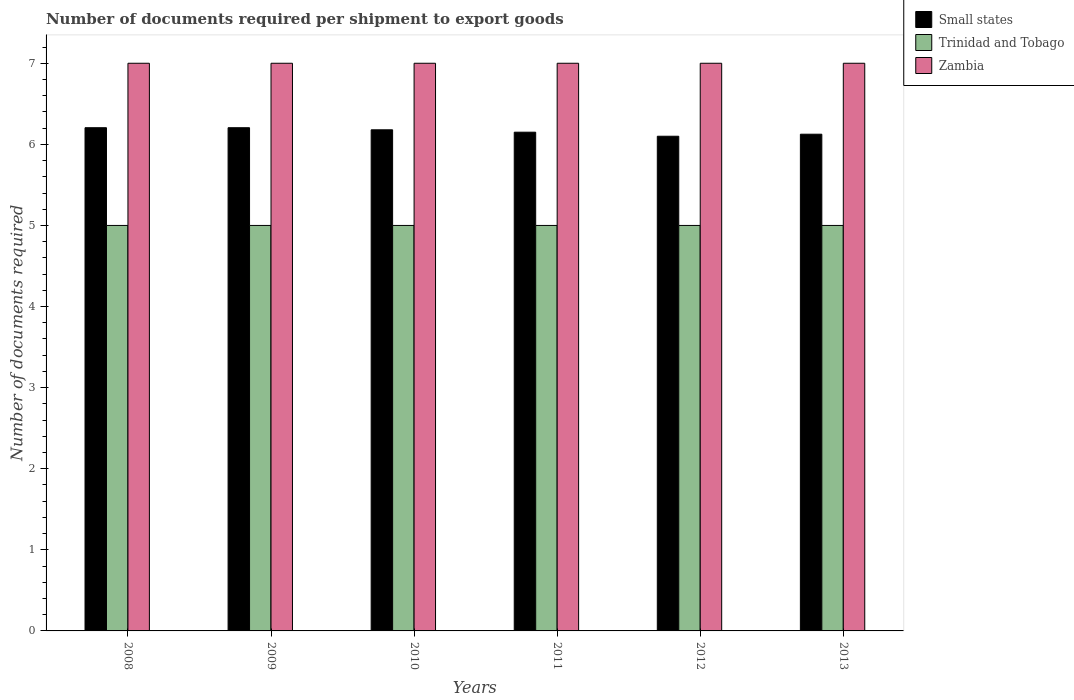Are the number of bars on each tick of the X-axis equal?
Keep it short and to the point. Yes. How many bars are there on the 1st tick from the left?
Offer a very short reply. 3. How many bars are there on the 2nd tick from the right?
Give a very brief answer. 3. What is the label of the 5th group of bars from the left?
Provide a succinct answer. 2012. What is the number of documents required per shipment to export goods in Small states in 2011?
Your response must be concise. 6.15. Across all years, what is the maximum number of documents required per shipment to export goods in Small states?
Your answer should be compact. 6.21. In which year was the number of documents required per shipment to export goods in Trinidad and Tobago maximum?
Offer a terse response. 2008. In which year was the number of documents required per shipment to export goods in Small states minimum?
Offer a very short reply. 2012. What is the total number of documents required per shipment to export goods in Small states in the graph?
Your answer should be compact. 36.96. What is the difference between the number of documents required per shipment to export goods in Trinidad and Tobago in 2011 and the number of documents required per shipment to export goods in Zambia in 2009?
Your answer should be very brief. -2. In the year 2010, what is the difference between the number of documents required per shipment to export goods in Zambia and number of documents required per shipment to export goods in Trinidad and Tobago?
Keep it short and to the point. 2. What is the ratio of the number of documents required per shipment to export goods in Trinidad and Tobago in 2012 to that in 2013?
Give a very brief answer. 1. Is the number of documents required per shipment to export goods in Small states in 2008 less than that in 2009?
Make the answer very short. No. Is the difference between the number of documents required per shipment to export goods in Zambia in 2008 and 2012 greater than the difference between the number of documents required per shipment to export goods in Trinidad and Tobago in 2008 and 2012?
Your answer should be compact. No. Is the sum of the number of documents required per shipment to export goods in Trinidad and Tobago in 2009 and 2011 greater than the maximum number of documents required per shipment to export goods in Zambia across all years?
Offer a very short reply. Yes. What does the 2nd bar from the left in 2012 represents?
Provide a succinct answer. Trinidad and Tobago. What does the 3rd bar from the right in 2009 represents?
Give a very brief answer. Small states. How many bars are there?
Provide a short and direct response. 18. Are all the bars in the graph horizontal?
Your response must be concise. No. Does the graph contain any zero values?
Provide a short and direct response. No. Where does the legend appear in the graph?
Ensure brevity in your answer.  Top right. How many legend labels are there?
Give a very brief answer. 3. What is the title of the graph?
Provide a short and direct response. Number of documents required per shipment to export goods. Does "Congo (Democratic)" appear as one of the legend labels in the graph?
Your response must be concise. No. What is the label or title of the Y-axis?
Provide a short and direct response. Number of documents required. What is the Number of documents required in Small states in 2008?
Give a very brief answer. 6.21. What is the Number of documents required of Zambia in 2008?
Give a very brief answer. 7. What is the Number of documents required in Small states in 2009?
Your response must be concise. 6.21. What is the Number of documents required in Zambia in 2009?
Make the answer very short. 7. What is the Number of documents required in Small states in 2010?
Your response must be concise. 6.18. What is the Number of documents required of Zambia in 2010?
Provide a short and direct response. 7. What is the Number of documents required in Small states in 2011?
Your answer should be compact. 6.15. What is the Number of documents required in Small states in 2012?
Ensure brevity in your answer.  6.1. What is the Number of documents required in Trinidad and Tobago in 2012?
Your answer should be compact. 5. What is the Number of documents required in Small states in 2013?
Make the answer very short. 6.12. Across all years, what is the maximum Number of documents required in Small states?
Keep it short and to the point. 6.21. Across all years, what is the minimum Number of documents required of Small states?
Provide a short and direct response. 6.1. Across all years, what is the minimum Number of documents required in Trinidad and Tobago?
Your response must be concise. 5. What is the total Number of documents required in Small states in the graph?
Your answer should be very brief. 36.96. What is the total Number of documents required of Trinidad and Tobago in the graph?
Provide a succinct answer. 30. What is the difference between the Number of documents required in Small states in 2008 and that in 2009?
Give a very brief answer. 0. What is the difference between the Number of documents required in Zambia in 2008 and that in 2009?
Offer a terse response. 0. What is the difference between the Number of documents required of Small states in 2008 and that in 2010?
Your response must be concise. 0.03. What is the difference between the Number of documents required of Trinidad and Tobago in 2008 and that in 2010?
Your response must be concise. 0. What is the difference between the Number of documents required in Zambia in 2008 and that in 2010?
Provide a succinct answer. 0. What is the difference between the Number of documents required in Small states in 2008 and that in 2011?
Provide a succinct answer. 0.06. What is the difference between the Number of documents required in Zambia in 2008 and that in 2011?
Your response must be concise. 0. What is the difference between the Number of documents required of Small states in 2008 and that in 2012?
Provide a succinct answer. 0.11. What is the difference between the Number of documents required of Trinidad and Tobago in 2008 and that in 2012?
Your answer should be compact. 0. What is the difference between the Number of documents required of Small states in 2008 and that in 2013?
Provide a succinct answer. 0.08. What is the difference between the Number of documents required in Trinidad and Tobago in 2008 and that in 2013?
Your answer should be compact. 0. What is the difference between the Number of documents required of Small states in 2009 and that in 2010?
Provide a short and direct response. 0.03. What is the difference between the Number of documents required in Trinidad and Tobago in 2009 and that in 2010?
Make the answer very short. 0. What is the difference between the Number of documents required of Small states in 2009 and that in 2011?
Give a very brief answer. 0.06. What is the difference between the Number of documents required of Trinidad and Tobago in 2009 and that in 2011?
Give a very brief answer. 0. What is the difference between the Number of documents required in Small states in 2009 and that in 2012?
Give a very brief answer. 0.11. What is the difference between the Number of documents required of Zambia in 2009 and that in 2012?
Offer a terse response. 0. What is the difference between the Number of documents required of Small states in 2009 and that in 2013?
Offer a terse response. 0.08. What is the difference between the Number of documents required in Trinidad and Tobago in 2009 and that in 2013?
Offer a very short reply. 0. What is the difference between the Number of documents required in Small states in 2010 and that in 2011?
Your answer should be very brief. 0.03. What is the difference between the Number of documents required of Trinidad and Tobago in 2010 and that in 2011?
Ensure brevity in your answer.  0. What is the difference between the Number of documents required of Zambia in 2010 and that in 2011?
Offer a very short reply. 0. What is the difference between the Number of documents required in Small states in 2010 and that in 2012?
Make the answer very short. 0.08. What is the difference between the Number of documents required of Trinidad and Tobago in 2010 and that in 2012?
Make the answer very short. 0. What is the difference between the Number of documents required in Small states in 2010 and that in 2013?
Ensure brevity in your answer.  0.05. What is the difference between the Number of documents required of Trinidad and Tobago in 2011 and that in 2012?
Offer a terse response. 0. What is the difference between the Number of documents required in Small states in 2011 and that in 2013?
Provide a succinct answer. 0.03. What is the difference between the Number of documents required in Small states in 2012 and that in 2013?
Ensure brevity in your answer.  -0.03. What is the difference between the Number of documents required of Trinidad and Tobago in 2012 and that in 2013?
Your answer should be compact. 0. What is the difference between the Number of documents required in Zambia in 2012 and that in 2013?
Ensure brevity in your answer.  0. What is the difference between the Number of documents required in Small states in 2008 and the Number of documents required in Trinidad and Tobago in 2009?
Keep it short and to the point. 1.21. What is the difference between the Number of documents required in Small states in 2008 and the Number of documents required in Zambia in 2009?
Give a very brief answer. -0.79. What is the difference between the Number of documents required of Small states in 2008 and the Number of documents required of Trinidad and Tobago in 2010?
Offer a terse response. 1.21. What is the difference between the Number of documents required in Small states in 2008 and the Number of documents required in Zambia in 2010?
Give a very brief answer. -0.79. What is the difference between the Number of documents required of Small states in 2008 and the Number of documents required of Trinidad and Tobago in 2011?
Provide a short and direct response. 1.21. What is the difference between the Number of documents required in Small states in 2008 and the Number of documents required in Zambia in 2011?
Your answer should be compact. -0.79. What is the difference between the Number of documents required in Small states in 2008 and the Number of documents required in Trinidad and Tobago in 2012?
Offer a terse response. 1.21. What is the difference between the Number of documents required of Small states in 2008 and the Number of documents required of Zambia in 2012?
Keep it short and to the point. -0.79. What is the difference between the Number of documents required of Trinidad and Tobago in 2008 and the Number of documents required of Zambia in 2012?
Provide a short and direct response. -2. What is the difference between the Number of documents required in Small states in 2008 and the Number of documents required in Trinidad and Tobago in 2013?
Provide a succinct answer. 1.21. What is the difference between the Number of documents required in Small states in 2008 and the Number of documents required in Zambia in 2013?
Your answer should be very brief. -0.79. What is the difference between the Number of documents required of Small states in 2009 and the Number of documents required of Trinidad and Tobago in 2010?
Your answer should be very brief. 1.21. What is the difference between the Number of documents required in Small states in 2009 and the Number of documents required in Zambia in 2010?
Offer a very short reply. -0.79. What is the difference between the Number of documents required in Trinidad and Tobago in 2009 and the Number of documents required in Zambia in 2010?
Offer a terse response. -2. What is the difference between the Number of documents required in Small states in 2009 and the Number of documents required in Trinidad and Tobago in 2011?
Your response must be concise. 1.21. What is the difference between the Number of documents required in Small states in 2009 and the Number of documents required in Zambia in 2011?
Provide a succinct answer. -0.79. What is the difference between the Number of documents required of Trinidad and Tobago in 2009 and the Number of documents required of Zambia in 2011?
Ensure brevity in your answer.  -2. What is the difference between the Number of documents required of Small states in 2009 and the Number of documents required of Trinidad and Tobago in 2012?
Keep it short and to the point. 1.21. What is the difference between the Number of documents required of Small states in 2009 and the Number of documents required of Zambia in 2012?
Provide a succinct answer. -0.79. What is the difference between the Number of documents required in Trinidad and Tobago in 2009 and the Number of documents required in Zambia in 2012?
Make the answer very short. -2. What is the difference between the Number of documents required in Small states in 2009 and the Number of documents required in Trinidad and Tobago in 2013?
Offer a very short reply. 1.21. What is the difference between the Number of documents required in Small states in 2009 and the Number of documents required in Zambia in 2013?
Provide a short and direct response. -0.79. What is the difference between the Number of documents required of Trinidad and Tobago in 2009 and the Number of documents required of Zambia in 2013?
Your answer should be very brief. -2. What is the difference between the Number of documents required in Small states in 2010 and the Number of documents required in Trinidad and Tobago in 2011?
Provide a short and direct response. 1.18. What is the difference between the Number of documents required in Small states in 2010 and the Number of documents required in Zambia in 2011?
Give a very brief answer. -0.82. What is the difference between the Number of documents required in Trinidad and Tobago in 2010 and the Number of documents required in Zambia in 2011?
Make the answer very short. -2. What is the difference between the Number of documents required of Small states in 2010 and the Number of documents required of Trinidad and Tobago in 2012?
Provide a succinct answer. 1.18. What is the difference between the Number of documents required of Small states in 2010 and the Number of documents required of Zambia in 2012?
Give a very brief answer. -0.82. What is the difference between the Number of documents required of Trinidad and Tobago in 2010 and the Number of documents required of Zambia in 2012?
Offer a very short reply. -2. What is the difference between the Number of documents required of Small states in 2010 and the Number of documents required of Trinidad and Tobago in 2013?
Your answer should be very brief. 1.18. What is the difference between the Number of documents required of Small states in 2010 and the Number of documents required of Zambia in 2013?
Offer a very short reply. -0.82. What is the difference between the Number of documents required in Small states in 2011 and the Number of documents required in Trinidad and Tobago in 2012?
Your answer should be compact. 1.15. What is the difference between the Number of documents required of Small states in 2011 and the Number of documents required of Zambia in 2012?
Provide a short and direct response. -0.85. What is the difference between the Number of documents required of Small states in 2011 and the Number of documents required of Trinidad and Tobago in 2013?
Offer a very short reply. 1.15. What is the difference between the Number of documents required of Small states in 2011 and the Number of documents required of Zambia in 2013?
Keep it short and to the point. -0.85. What is the difference between the Number of documents required in Trinidad and Tobago in 2012 and the Number of documents required in Zambia in 2013?
Your answer should be compact. -2. What is the average Number of documents required of Small states per year?
Provide a succinct answer. 6.16. What is the average Number of documents required of Trinidad and Tobago per year?
Ensure brevity in your answer.  5. In the year 2008, what is the difference between the Number of documents required in Small states and Number of documents required in Trinidad and Tobago?
Give a very brief answer. 1.21. In the year 2008, what is the difference between the Number of documents required of Small states and Number of documents required of Zambia?
Your response must be concise. -0.79. In the year 2009, what is the difference between the Number of documents required in Small states and Number of documents required in Trinidad and Tobago?
Give a very brief answer. 1.21. In the year 2009, what is the difference between the Number of documents required in Small states and Number of documents required in Zambia?
Your answer should be compact. -0.79. In the year 2009, what is the difference between the Number of documents required of Trinidad and Tobago and Number of documents required of Zambia?
Ensure brevity in your answer.  -2. In the year 2010, what is the difference between the Number of documents required in Small states and Number of documents required in Trinidad and Tobago?
Provide a short and direct response. 1.18. In the year 2010, what is the difference between the Number of documents required of Small states and Number of documents required of Zambia?
Provide a succinct answer. -0.82. In the year 2011, what is the difference between the Number of documents required in Small states and Number of documents required in Trinidad and Tobago?
Your response must be concise. 1.15. In the year 2011, what is the difference between the Number of documents required in Small states and Number of documents required in Zambia?
Your answer should be very brief. -0.85. In the year 2012, what is the difference between the Number of documents required of Small states and Number of documents required of Trinidad and Tobago?
Make the answer very short. 1.1. In the year 2013, what is the difference between the Number of documents required of Small states and Number of documents required of Zambia?
Provide a short and direct response. -0.88. In the year 2013, what is the difference between the Number of documents required of Trinidad and Tobago and Number of documents required of Zambia?
Keep it short and to the point. -2. What is the ratio of the Number of documents required of Trinidad and Tobago in 2008 to that in 2009?
Make the answer very short. 1. What is the ratio of the Number of documents required of Small states in 2008 to that in 2010?
Make the answer very short. 1. What is the ratio of the Number of documents required in Zambia in 2008 to that in 2010?
Make the answer very short. 1. What is the ratio of the Number of documents required in Small states in 2008 to that in 2011?
Your answer should be compact. 1.01. What is the ratio of the Number of documents required of Trinidad and Tobago in 2008 to that in 2011?
Your answer should be very brief. 1. What is the ratio of the Number of documents required of Small states in 2008 to that in 2012?
Your response must be concise. 1.02. What is the ratio of the Number of documents required of Trinidad and Tobago in 2008 to that in 2012?
Make the answer very short. 1. What is the ratio of the Number of documents required in Small states in 2008 to that in 2013?
Offer a terse response. 1.01. What is the ratio of the Number of documents required in Trinidad and Tobago in 2008 to that in 2013?
Your answer should be very brief. 1. What is the ratio of the Number of documents required of Small states in 2009 to that in 2010?
Ensure brevity in your answer.  1. What is the ratio of the Number of documents required in Zambia in 2009 to that in 2010?
Give a very brief answer. 1. What is the ratio of the Number of documents required of Small states in 2009 to that in 2011?
Offer a very short reply. 1.01. What is the ratio of the Number of documents required in Trinidad and Tobago in 2009 to that in 2011?
Your answer should be compact. 1. What is the ratio of the Number of documents required in Zambia in 2009 to that in 2011?
Provide a succinct answer. 1. What is the ratio of the Number of documents required of Small states in 2009 to that in 2012?
Offer a terse response. 1.02. What is the ratio of the Number of documents required in Zambia in 2009 to that in 2012?
Your answer should be compact. 1. What is the ratio of the Number of documents required of Small states in 2009 to that in 2013?
Make the answer very short. 1.01. What is the ratio of the Number of documents required of Trinidad and Tobago in 2009 to that in 2013?
Your answer should be very brief. 1. What is the ratio of the Number of documents required of Trinidad and Tobago in 2010 to that in 2011?
Provide a short and direct response. 1. What is the ratio of the Number of documents required of Zambia in 2010 to that in 2011?
Offer a terse response. 1. What is the ratio of the Number of documents required of Trinidad and Tobago in 2010 to that in 2012?
Make the answer very short. 1. What is the ratio of the Number of documents required in Zambia in 2010 to that in 2012?
Ensure brevity in your answer.  1. What is the ratio of the Number of documents required of Small states in 2010 to that in 2013?
Your answer should be compact. 1.01. What is the ratio of the Number of documents required of Trinidad and Tobago in 2010 to that in 2013?
Your response must be concise. 1. What is the ratio of the Number of documents required of Small states in 2011 to that in 2012?
Offer a terse response. 1.01. What is the ratio of the Number of documents required in Trinidad and Tobago in 2011 to that in 2012?
Provide a short and direct response. 1. What is the ratio of the Number of documents required of Zambia in 2011 to that in 2012?
Your response must be concise. 1. What is the ratio of the Number of documents required in Small states in 2011 to that in 2013?
Offer a very short reply. 1. What is the ratio of the Number of documents required of Small states in 2012 to that in 2013?
Your response must be concise. 1. What is the difference between the highest and the second highest Number of documents required of Small states?
Offer a very short reply. 0. What is the difference between the highest and the second highest Number of documents required of Trinidad and Tobago?
Your answer should be compact. 0. What is the difference between the highest and the lowest Number of documents required in Small states?
Your response must be concise. 0.11. 